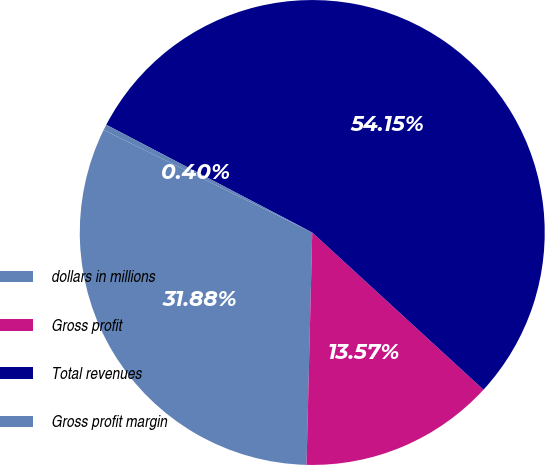Convert chart to OTSL. <chart><loc_0><loc_0><loc_500><loc_500><pie_chart><fcel>dollars in millions<fcel>Gross profit<fcel>Total revenues<fcel>Gross profit margin<nl><fcel>31.88%<fcel>13.57%<fcel>54.15%<fcel>0.4%<nl></chart> 